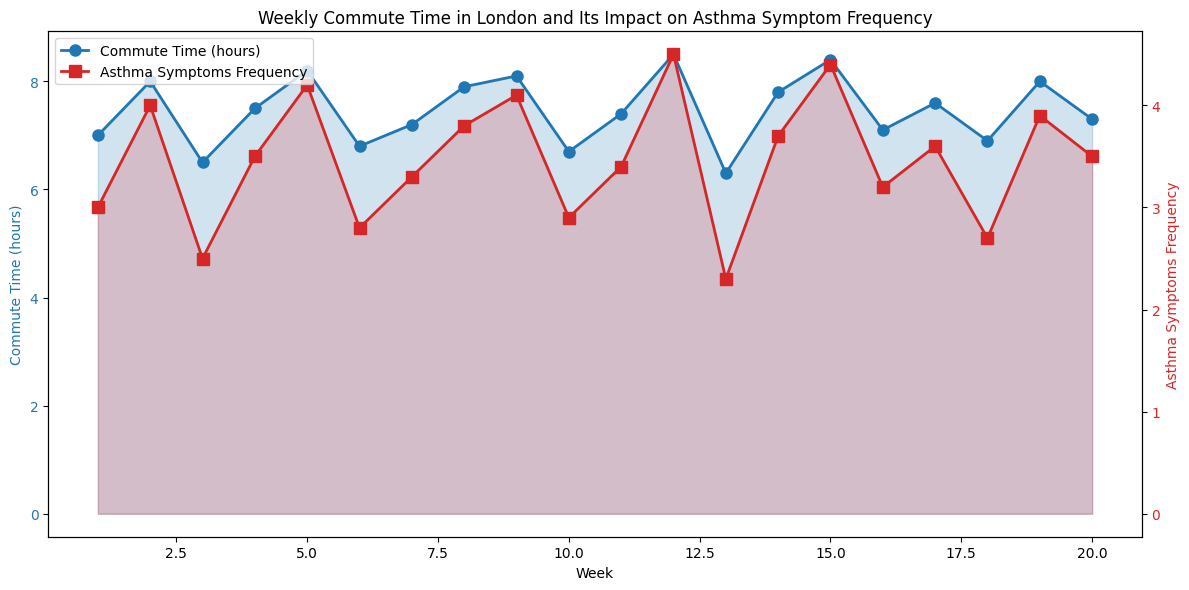What is the overall trend in commute time throughout the 20 weeks? The commute time generally fluctuates but follows an upward trend with some peaks, notably around Weeks 5, 9, 12, 15, and 19, when the highest commute times are observed.
Answer: Upward trend Which week had the highest asthma symptom frequency? By observing the red line representing asthma symptoms frequency, we can see that Week 12 has the highest peak in symptoms frequency.
Answer: Week 12 How does the asthma symptom frequency in Week 10 compare to that in Week 11? In Week 10, the asthma symptom frequency is slightly lower as compared to Week 11, approximately 2.9 vs. 3.4 respectively.
Answer: Week 11 > Week 10 What is the average asthma symptoms frequency over the 20 weeks? Summing up the asthma symptoms frequencies and dividing by 20: (3 + 4 + 2.5 + 3.5 + 4.2 + 2.8 + 3.3 + 3.8 + 4.1 + 2.9 + 3.4 + 4.5 + 2.3 + 3.7 + 4.4 + 3.2 + 3.6 + 2.7 + 3.9 + 3.5) / 20 = 3.4
Answer: 3.4 During which weeks does the commute time exceed 8 hours, and what are the corresponding asthma symptom frequencies for those weeks? The commute time exceeds 8 hours during Weeks 5 (8.2 hours), 9 (8.1 hours), 12 (8.5 hours), and 15 (8.4 hours). The corresponding asthma symptom frequencies are 4.2, 4.1, 4.5, and 4.4 respectively.
Answer: Weeks 5, 9, 12, 15 (frequencies: 4.2, 4.1, 4.5, 4.4) Is there a correlation between an increase in commute time and the frequency of asthma symptoms? By observing the patterns, there seems to be a positive correlation, meaning that as commute time increases, the frequency of asthma symptoms tends to increase as well, especially evident during the peaks in commuting hours and asthma symptoms in Weeks 9, 12, and 15.
Answer: Positive correlation Which week had the lowest asthma symptom frequency and what was the commute time during that week? The lowest asthma symptom frequency is observed in Week 13 with a frequency of 2.3. The commute time during that week was 6.3 hours.
Answer: Week 13 How many weeks had an asthma symptom frequency higher than 4.0? From the red line graph, it is clear that asthma symptom frequency exceeds 4.0 during Weeks 5, 9, 12, 15, and 19. That makes a total of 5 weeks.
Answer: 5 weeks 